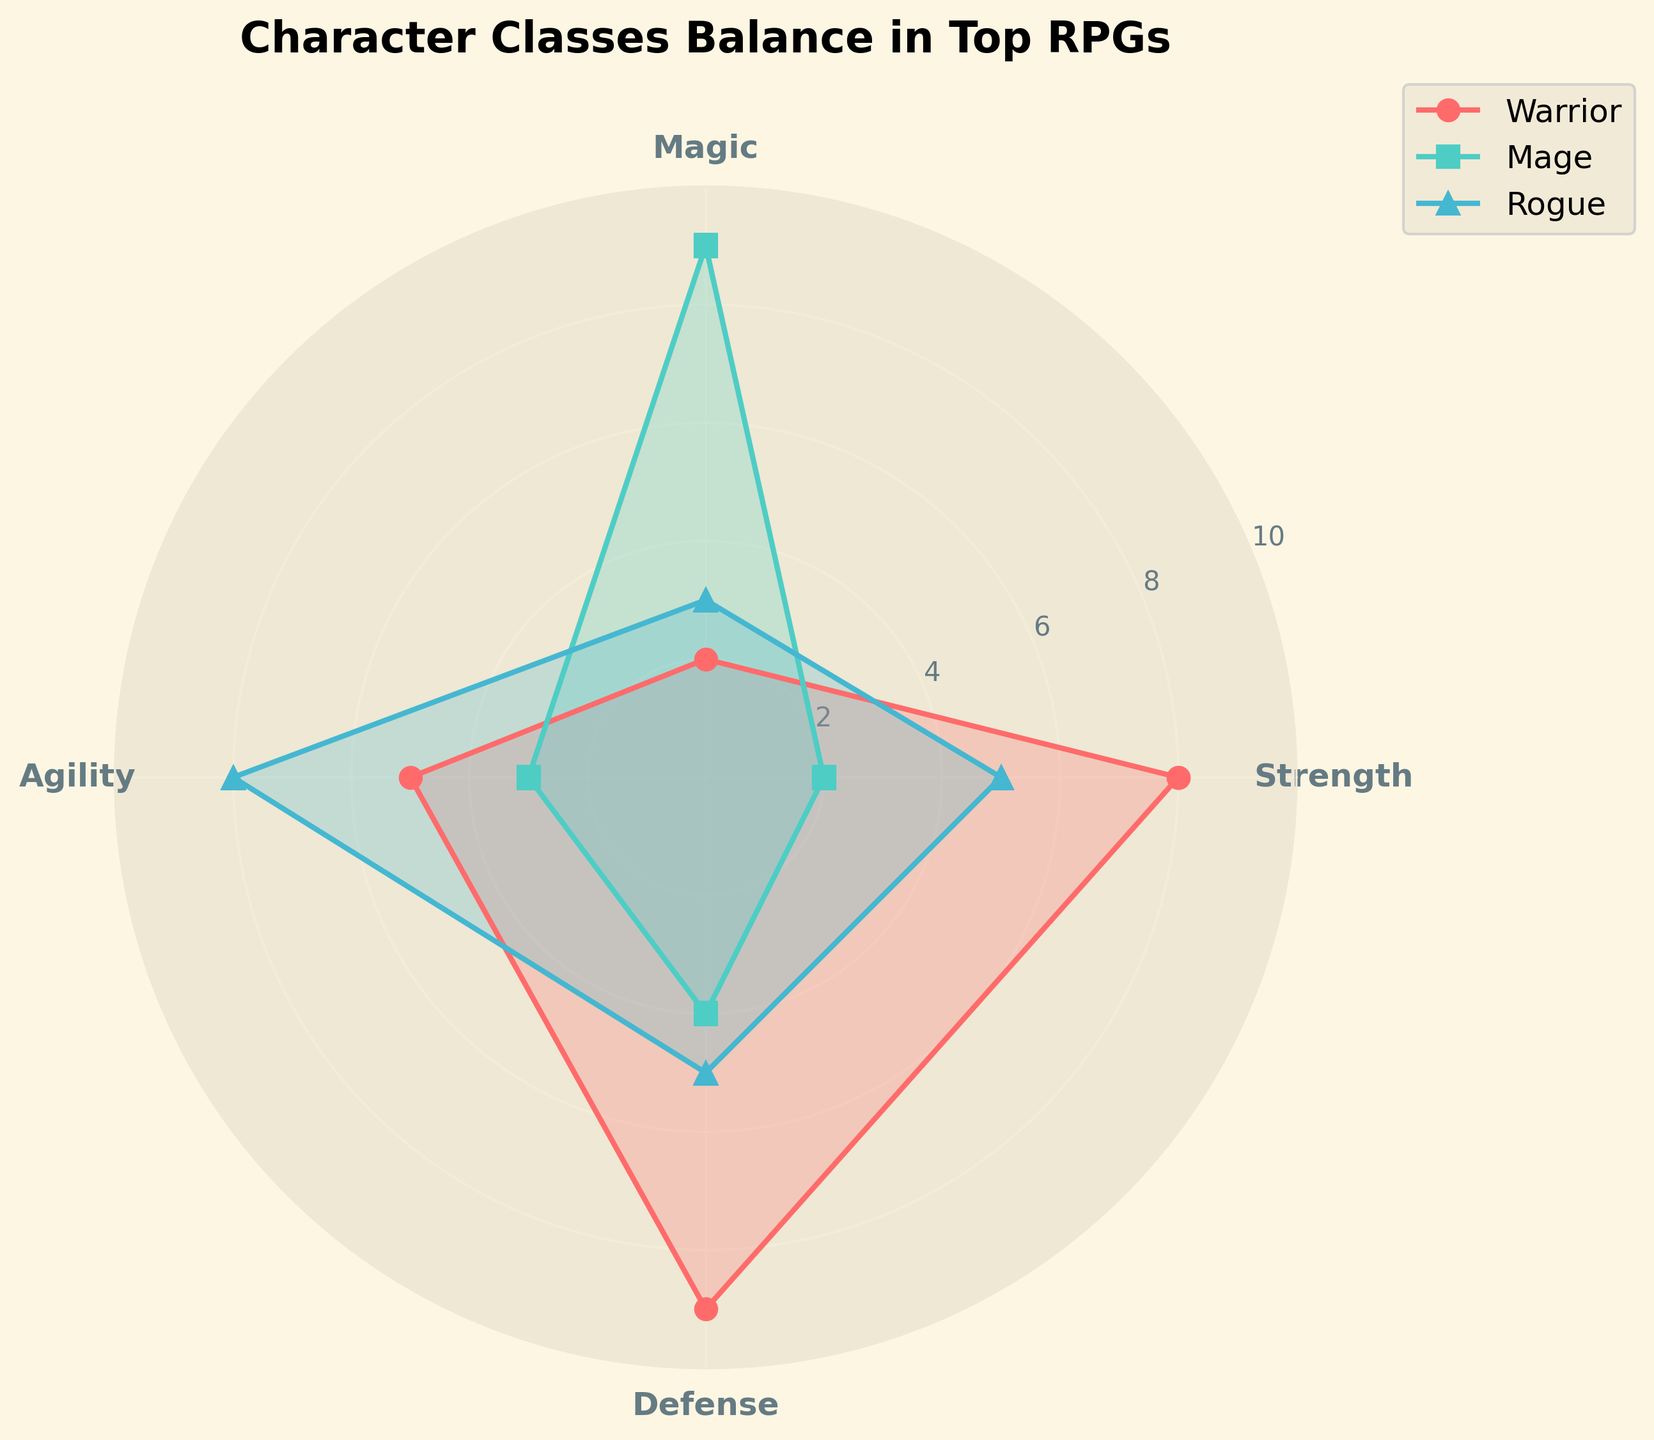Which character class is strongest in terms of strength? The figure shows the warrior as having the highest strength values.
Answer: Warrior Which character class has the highest magic ability? Based on the radar chart, the mage has the highest magic value compared to the other character classes.
Answer: Mage What is the average defense value across all character classes? The defense values are 9 (Warrior), 4 (Mage), 5 (Rogue) for the first set and 8 (Warrior), 5 (Mage), 6 (Rogue) for the second set. The average is calculated as (9+4+5+8+5+6)/6 = 37/6 ≈ 6.17.
Answer: 6.17 Which character class has the least agility in the second set of data points? The second set of agility values are: Warrior (4), Mage (2), Rogue (7). The lowest value corresponds to the mage.
Answer: Mage How does the agility of the rogue compare to that of the warrior in the first set? The agility values in the first set are 5 for the warrior and 8 for the rogue. Therefore, the rogue is more agile than the warrior.
Answer: Rogue is more agile What's the total strength of all character classes in the first set? The strength values for the first set are Warrior (8), Mage (2), Rogue (5). Adding these gives 8 + 2 + 5 = 15.
Answer: 15 Which character class shows the most balanced attributes in the first set? A balanced attribute spread implies a relatively even distribution across all four attributes. Comparing the classes: 
- Warrior: Strength (8), Magic (2), Agility (5), Defense (9) 
- Mage: Strength (2), Magic (9), Agility (3), Defense (4) 
- Rogue: Strength (5), Magic (3), Agility (8), Defense (5) 
The rogue has the most balanced spread.
Answer: Rogue Which attribute shows the largest difference between the first and second sets for the warrior class? For the warrior, the values are: 
- Strength: 8 (first set) vs 9 (second set) 
- Magic: 2 (first set) vs 3 (second set) 
- Agility: 5 (first set) vs 4 (second set) 
- Defense: 9 (first set) vs 8 (second set) 
The largest difference is in Strength, with a change of 1.
Answer: Strength (1) Does the mage have higher defense or higher agility in the second set of data points? In the second set, the mage has a defense value of 5 and an agility value of 2. Therefore, the mage has higher defense.
Answer: Defense Which character class has the highest average value across all attributes in the first data set? Calculate the averages for each class in the first set:
- Warrior: (8 + 2 + 5 + 9) / 4 = 6
- Mage: (2 + 9 + 3 + 4) / 4 = 4.5
- Rogue: (5 + 3 + 8 + 5) / 4 = 5.25
The warrior has the highest average value.
Answer: Warrior 